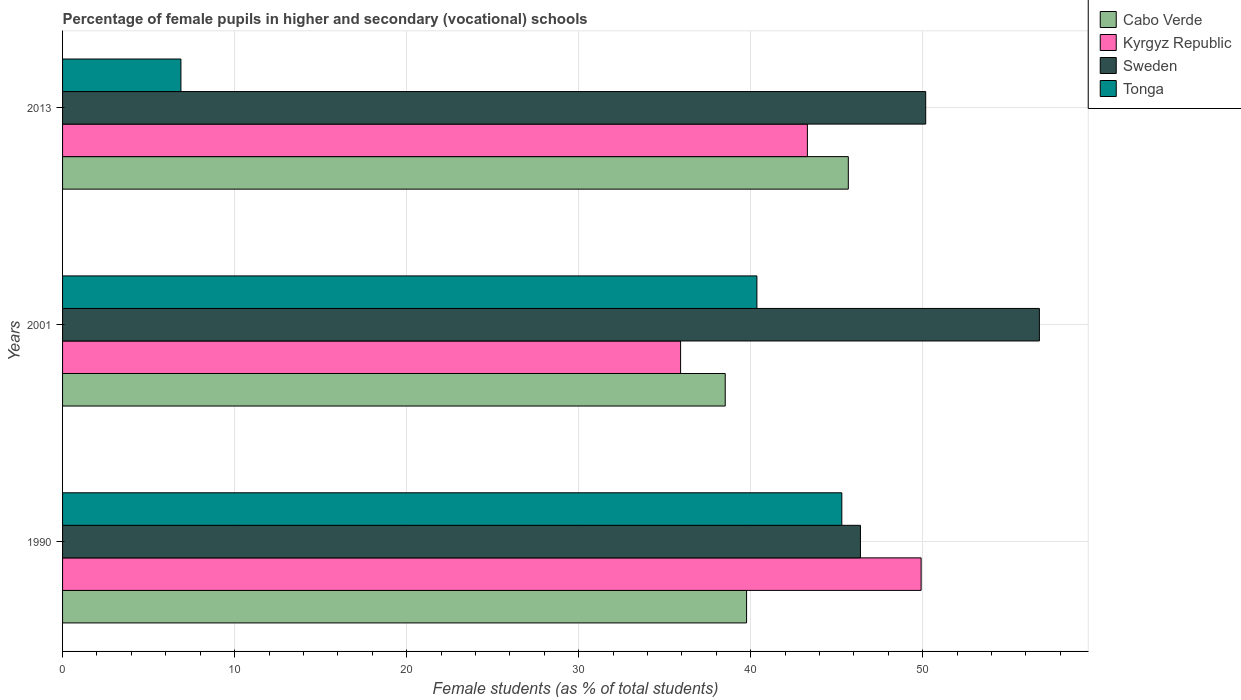How many different coloured bars are there?
Offer a very short reply. 4. How many groups of bars are there?
Offer a very short reply. 3. How many bars are there on the 3rd tick from the bottom?
Provide a succinct answer. 4. In how many cases, is the number of bars for a given year not equal to the number of legend labels?
Your answer should be compact. 0. What is the percentage of female pupils in higher and secondary schools in Cabo Verde in 1990?
Provide a short and direct response. 39.76. Across all years, what is the maximum percentage of female pupils in higher and secondary schools in Tonga?
Offer a very short reply. 45.3. Across all years, what is the minimum percentage of female pupils in higher and secondary schools in Kyrgyz Republic?
Give a very brief answer. 35.93. In which year was the percentage of female pupils in higher and secondary schools in Tonga minimum?
Provide a succinct answer. 2013. What is the total percentage of female pupils in higher and secondary schools in Sweden in the graph?
Your response must be concise. 153.34. What is the difference between the percentage of female pupils in higher and secondary schools in Tonga in 2001 and that in 2013?
Your response must be concise. 33.48. What is the difference between the percentage of female pupils in higher and secondary schools in Kyrgyz Republic in 1990 and the percentage of female pupils in higher and secondary schools in Cabo Verde in 2013?
Your answer should be compact. 4.23. What is the average percentage of female pupils in higher and secondary schools in Sweden per year?
Offer a very short reply. 51.11. In the year 1990, what is the difference between the percentage of female pupils in higher and secondary schools in Sweden and percentage of female pupils in higher and secondary schools in Kyrgyz Republic?
Your answer should be very brief. -3.53. What is the ratio of the percentage of female pupils in higher and secondary schools in Tonga in 1990 to that in 2013?
Provide a succinct answer. 6.58. Is the percentage of female pupils in higher and secondary schools in Sweden in 2001 less than that in 2013?
Your response must be concise. No. What is the difference between the highest and the second highest percentage of female pupils in higher and secondary schools in Kyrgyz Republic?
Offer a terse response. 6.61. What is the difference between the highest and the lowest percentage of female pupils in higher and secondary schools in Sweden?
Your answer should be compact. 10.4. Is the sum of the percentage of female pupils in higher and secondary schools in Cabo Verde in 1990 and 2013 greater than the maximum percentage of female pupils in higher and secondary schools in Sweden across all years?
Give a very brief answer. Yes. Is it the case that in every year, the sum of the percentage of female pupils in higher and secondary schools in Kyrgyz Republic and percentage of female pupils in higher and secondary schools in Sweden is greater than the sum of percentage of female pupils in higher and secondary schools in Cabo Verde and percentage of female pupils in higher and secondary schools in Tonga?
Keep it short and to the point. Yes. What does the 1st bar from the bottom in 1990 represents?
Your answer should be very brief. Cabo Verde. Is it the case that in every year, the sum of the percentage of female pupils in higher and secondary schools in Tonga and percentage of female pupils in higher and secondary schools in Kyrgyz Republic is greater than the percentage of female pupils in higher and secondary schools in Sweden?
Offer a terse response. Yes. Are the values on the major ticks of X-axis written in scientific E-notation?
Your answer should be compact. No. Does the graph contain grids?
Ensure brevity in your answer.  Yes. Where does the legend appear in the graph?
Offer a terse response. Top right. How are the legend labels stacked?
Your answer should be compact. Vertical. What is the title of the graph?
Provide a succinct answer. Percentage of female pupils in higher and secondary (vocational) schools. What is the label or title of the X-axis?
Offer a terse response. Female students (as % of total students). What is the label or title of the Y-axis?
Provide a succinct answer. Years. What is the Female students (as % of total students) of Cabo Verde in 1990?
Your answer should be compact. 39.76. What is the Female students (as % of total students) in Kyrgyz Republic in 1990?
Offer a very short reply. 49.91. What is the Female students (as % of total students) of Sweden in 1990?
Your answer should be very brief. 46.38. What is the Female students (as % of total students) of Tonga in 1990?
Your response must be concise. 45.3. What is the Female students (as % of total students) in Cabo Verde in 2001?
Give a very brief answer. 38.52. What is the Female students (as % of total students) in Kyrgyz Republic in 2001?
Your response must be concise. 35.93. What is the Female students (as % of total students) of Sweden in 2001?
Your response must be concise. 56.78. What is the Female students (as % of total students) in Tonga in 2001?
Your response must be concise. 40.36. What is the Female students (as % of total students) in Cabo Verde in 2013?
Provide a short and direct response. 45.67. What is the Female students (as % of total students) of Kyrgyz Republic in 2013?
Provide a short and direct response. 43.3. What is the Female students (as % of total students) of Sweden in 2013?
Your answer should be compact. 50.17. What is the Female students (as % of total students) of Tonga in 2013?
Keep it short and to the point. 6.88. Across all years, what is the maximum Female students (as % of total students) of Cabo Verde?
Give a very brief answer. 45.67. Across all years, what is the maximum Female students (as % of total students) of Kyrgyz Republic?
Your response must be concise. 49.91. Across all years, what is the maximum Female students (as % of total students) in Sweden?
Offer a terse response. 56.78. Across all years, what is the maximum Female students (as % of total students) of Tonga?
Ensure brevity in your answer.  45.3. Across all years, what is the minimum Female students (as % of total students) in Cabo Verde?
Your response must be concise. 38.52. Across all years, what is the minimum Female students (as % of total students) of Kyrgyz Republic?
Your answer should be very brief. 35.93. Across all years, what is the minimum Female students (as % of total students) in Sweden?
Make the answer very short. 46.38. Across all years, what is the minimum Female students (as % of total students) in Tonga?
Your answer should be very brief. 6.88. What is the total Female students (as % of total students) in Cabo Verde in the graph?
Offer a terse response. 123.96. What is the total Female students (as % of total students) in Kyrgyz Republic in the graph?
Your answer should be very brief. 129.13. What is the total Female students (as % of total students) of Sweden in the graph?
Make the answer very short. 153.34. What is the total Female students (as % of total students) of Tonga in the graph?
Ensure brevity in your answer.  92.54. What is the difference between the Female students (as % of total students) in Cabo Verde in 1990 and that in 2001?
Make the answer very short. 1.24. What is the difference between the Female students (as % of total students) in Kyrgyz Republic in 1990 and that in 2001?
Make the answer very short. 13.98. What is the difference between the Female students (as % of total students) in Sweden in 1990 and that in 2001?
Your answer should be compact. -10.4. What is the difference between the Female students (as % of total students) of Tonga in 1990 and that in 2001?
Make the answer very short. 4.94. What is the difference between the Female students (as % of total students) of Cabo Verde in 1990 and that in 2013?
Provide a succinct answer. -5.91. What is the difference between the Female students (as % of total students) of Kyrgyz Republic in 1990 and that in 2013?
Ensure brevity in your answer.  6.61. What is the difference between the Female students (as % of total students) of Sweden in 1990 and that in 2013?
Provide a short and direct response. -3.79. What is the difference between the Female students (as % of total students) of Tonga in 1990 and that in 2013?
Ensure brevity in your answer.  38.42. What is the difference between the Female students (as % of total students) in Cabo Verde in 2001 and that in 2013?
Provide a succinct answer. -7.16. What is the difference between the Female students (as % of total students) in Kyrgyz Republic in 2001 and that in 2013?
Provide a short and direct response. -7.37. What is the difference between the Female students (as % of total students) of Sweden in 2001 and that in 2013?
Provide a succinct answer. 6.61. What is the difference between the Female students (as % of total students) of Tonga in 2001 and that in 2013?
Provide a short and direct response. 33.48. What is the difference between the Female students (as % of total students) of Cabo Verde in 1990 and the Female students (as % of total students) of Kyrgyz Republic in 2001?
Provide a succinct answer. 3.84. What is the difference between the Female students (as % of total students) in Cabo Verde in 1990 and the Female students (as % of total students) in Sweden in 2001?
Your answer should be very brief. -17.02. What is the difference between the Female students (as % of total students) of Cabo Verde in 1990 and the Female students (as % of total students) of Tonga in 2001?
Offer a very short reply. -0.6. What is the difference between the Female students (as % of total students) of Kyrgyz Republic in 1990 and the Female students (as % of total students) of Sweden in 2001?
Keep it short and to the point. -6.87. What is the difference between the Female students (as % of total students) of Kyrgyz Republic in 1990 and the Female students (as % of total students) of Tonga in 2001?
Your answer should be compact. 9.55. What is the difference between the Female students (as % of total students) of Sweden in 1990 and the Female students (as % of total students) of Tonga in 2001?
Your answer should be compact. 6.02. What is the difference between the Female students (as % of total students) of Cabo Verde in 1990 and the Female students (as % of total students) of Kyrgyz Republic in 2013?
Provide a succinct answer. -3.54. What is the difference between the Female students (as % of total students) in Cabo Verde in 1990 and the Female students (as % of total students) in Sweden in 2013?
Your response must be concise. -10.41. What is the difference between the Female students (as % of total students) in Cabo Verde in 1990 and the Female students (as % of total students) in Tonga in 2013?
Keep it short and to the point. 32.88. What is the difference between the Female students (as % of total students) in Kyrgyz Republic in 1990 and the Female students (as % of total students) in Sweden in 2013?
Provide a succinct answer. -0.27. What is the difference between the Female students (as % of total students) of Kyrgyz Republic in 1990 and the Female students (as % of total students) of Tonga in 2013?
Provide a succinct answer. 43.03. What is the difference between the Female students (as % of total students) in Sweden in 1990 and the Female students (as % of total students) in Tonga in 2013?
Offer a terse response. 39.5. What is the difference between the Female students (as % of total students) of Cabo Verde in 2001 and the Female students (as % of total students) of Kyrgyz Republic in 2013?
Give a very brief answer. -4.78. What is the difference between the Female students (as % of total students) in Cabo Verde in 2001 and the Female students (as % of total students) in Sweden in 2013?
Provide a short and direct response. -11.65. What is the difference between the Female students (as % of total students) of Cabo Verde in 2001 and the Female students (as % of total students) of Tonga in 2013?
Provide a short and direct response. 31.64. What is the difference between the Female students (as % of total students) of Kyrgyz Republic in 2001 and the Female students (as % of total students) of Sweden in 2013?
Your answer should be compact. -14.25. What is the difference between the Female students (as % of total students) of Kyrgyz Republic in 2001 and the Female students (as % of total students) of Tonga in 2013?
Give a very brief answer. 29.05. What is the difference between the Female students (as % of total students) in Sweden in 2001 and the Female students (as % of total students) in Tonga in 2013?
Provide a short and direct response. 49.9. What is the average Female students (as % of total students) of Cabo Verde per year?
Make the answer very short. 41.32. What is the average Female students (as % of total students) in Kyrgyz Republic per year?
Ensure brevity in your answer.  43.04. What is the average Female students (as % of total students) in Sweden per year?
Offer a very short reply. 51.11. What is the average Female students (as % of total students) in Tonga per year?
Your answer should be compact. 30.85. In the year 1990, what is the difference between the Female students (as % of total students) in Cabo Verde and Female students (as % of total students) in Kyrgyz Republic?
Give a very brief answer. -10.15. In the year 1990, what is the difference between the Female students (as % of total students) of Cabo Verde and Female students (as % of total students) of Sweden?
Your answer should be compact. -6.62. In the year 1990, what is the difference between the Female students (as % of total students) in Cabo Verde and Female students (as % of total students) in Tonga?
Your answer should be compact. -5.54. In the year 1990, what is the difference between the Female students (as % of total students) of Kyrgyz Republic and Female students (as % of total students) of Sweden?
Keep it short and to the point. 3.53. In the year 1990, what is the difference between the Female students (as % of total students) in Kyrgyz Republic and Female students (as % of total students) in Tonga?
Provide a short and direct response. 4.61. In the year 1990, what is the difference between the Female students (as % of total students) in Sweden and Female students (as % of total students) in Tonga?
Make the answer very short. 1.08. In the year 2001, what is the difference between the Female students (as % of total students) of Cabo Verde and Female students (as % of total students) of Kyrgyz Republic?
Offer a terse response. 2.59. In the year 2001, what is the difference between the Female students (as % of total students) in Cabo Verde and Female students (as % of total students) in Sweden?
Offer a terse response. -18.26. In the year 2001, what is the difference between the Female students (as % of total students) of Cabo Verde and Female students (as % of total students) of Tonga?
Offer a very short reply. -1.84. In the year 2001, what is the difference between the Female students (as % of total students) of Kyrgyz Republic and Female students (as % of total students) of Sweden?
Make the answer very short. -20.86. In the year 2001, what is the difference between the Female students (as % of total students) of Kyrgyz Republic and Female students (as % of total students) of Tonga?
Your answer should be very brief. -4.44. In the year 2001, what is the difference between the Female students (as % of total students) in Sweden and Female students (as % of total students) in Tonga?
Offer a terse response. 16.42. In the year 2013, what is the difference between the Female students (as % of total students) in Cabo Verde and Female students (as % of total students) in Kyrgyz Republic?
Keep it short and to the point. 2.38. In the year 2013, what is the difference between the Female students (as % of total students) in Cabo Verde and Female students (as % of total students) in Sweden?
Keep it short and to the point. -4.5. In the year 2013, what is the difference between the Female students (as % of total students) of Cabo Verde and Female students (as % of total students) of Tonga?
Your answer should be compact. 38.8. In the year 2013, what is the difference between the Female students (as % of total students) of Kyrgyz Republic and Female students (as % of total students) of Sweden?
Give a very brief answer. -6.88. In the year 2013, what is the difference between the Female students (as % of total students) in Kyrgyz Republic and Female students (as % of total students) in Tonga?
Offer a very short reply. 36.42. In the year 2013, what is the difference between the Female students (as % of total students) of Sweden and Female students (as % of total students) of Tonga?
Your response must be concise. 43.29. What is the ratio of the Female students (as % of total students) in Cabo Verde in 1990 to that in 2001?
Offer a very short reply. 1.03. What is the ratio of the Female students (as % of total students) of Kyrgyz Republic in 1990 to that in 2001?
Your response must be concise. 1.39. What is the ratio of the Female students (as % of total students) in Sweden in 1990 to that in 2001?
Your answer should be very brief. 0.82. What is the ratio of the Female students (as % of total students) of Tonga in 1990 to that in 2001?
Your response must be concise. 1.12. What is the ratio of the Female students (as % of total students) of Cabo Verde in 1990 to that in 2013?
Provide a short and direct response. 0.87. What is the ratio of the Female students (as % of total students) of Kyrgyz Republic in 1990 to that in 2013?
Offer a very short reply. 1.15. What is the ratio of the Female students (as % of total students) in Sweden in 1990 to that in 2013?
Your answer should be compact. 0.92. What is the ratio of the Female students (as % of total students) in Tonga in 1990 to that in 2013?
Keep it short and to the point. 6.58. What is the ratio of the Female students (as % of total students) in Cabo Verde in 2001 to that in 2013?
Give a very brief answer. 0.84. What is the ratio of the Female students (as % of total students) in Kyrgyz Republic in 2001 to that in 2013?
Make the answer very short. 0.83. What is the ratio of the Female students (as % of total students) in Sweden in 2001 to that in 2013?
Provide a short and direct response. 1.13. What is the ratio of the Female students (as % of total students) of Tonga in 2001 to that in 2013?
Give a very brief answer. 5.87. What is the difference between the highest and the second highest Female students (as % of total students) of Cabo Verde?
Offer a very short reply. 5.91. What is the difference between the highest and the second highest Female students (as % of total students) in Kyrgyz Republic?
Give a very brief answer. 6.61. What is the difference between the highest and the second highest Female students (as % of total students) of Sweden?
Ensure brevity in your answer.  6.61. What is the difference between the highest and the second highest Female students (as % of total students) in Tonga?
Give a very brief answer. 4.94. What is the difference between the highest and the lowest Female students (as % of total students) of Cabo Verde?
Provide a short and direct response. 7.16. What is the difference between the highest and the lowest Female students (as % of total students) in Kyrgyz Republic?
Your answer should be compact. 13.98. What is the difference between the highest and the lowest Female students (as % of total students) of Sweden?
Give a very brief answer. 10.4. What is the difference between the highest and the lowest Female students (as % of total students) in Tonga?
Offer a terse response. 38.42. 